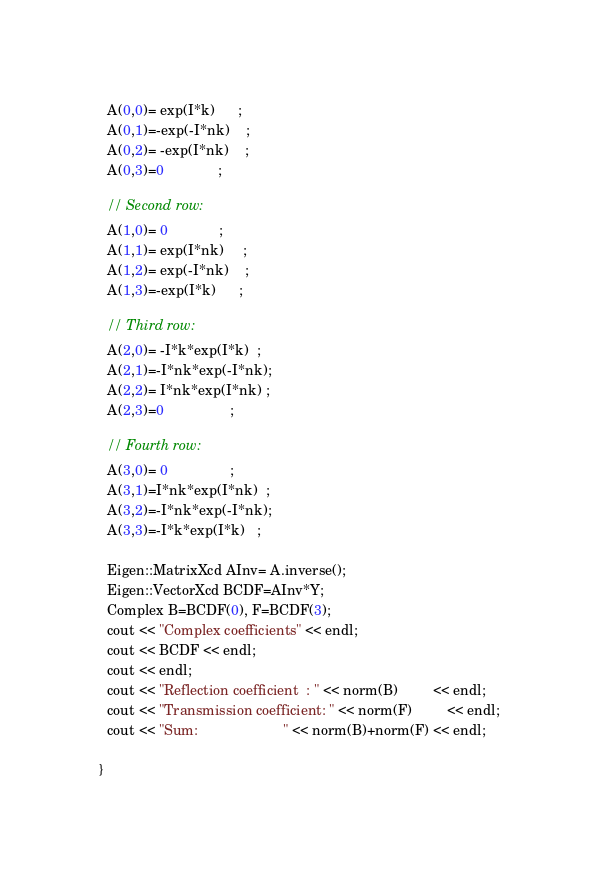Convert code to text. <code><loc_0><loc_0><loc_500><loc_500><_C++_>  A(0,0)= exp(I*k)      ;
  A(0,1)=-exp(-I*nk)    ; 
  A(0,2)= -exp(I*nk)    ; 
  A(0,3)=0              ;

  // Second row:
  A(1,0)= 0             ;
  A(1,1)= exp(I*nk)     ; 
  A(1,2)= exp(-I*nk)    ; 
  A(1,3)=-exp(I*k)      ;
  
  // Third row:
  A(2,0)= -I*k*exp(I*k)  ;
  A(2,1)=-I*nk*exp(-I*nk); 
  A(2,2)= I*nk*exp(I*nk) ; 
  A(2,3)=0                 ;

  // Fourth row:
  A(3,0)= 0                ;
  A(3,1)=I*nk*exp(I*nk)  ; 
  A(3,2)=-I*nk*exp(-I*nk); 
  A(3,3)=-I*k*exp(I*k)   ;

  Eigen::MatrixXcd AInv= A.inverse();
  Eigen::VectorXcd BCDF=AInv*Y;
  Complex B=BCDF(0), F=BCDF(3);
  cout << "Complex coefficients" << endl;
  cout << BCDF << endl;
  cout << endl;
  cout << "Reflection coefficient  : " << norm(B)         << endl;
  cout << "Transmission coefficient: " << norm(F)         << endl;
  cout << "Sum:                      " << norm(B)+norm(F) << endl;

}
</code> 